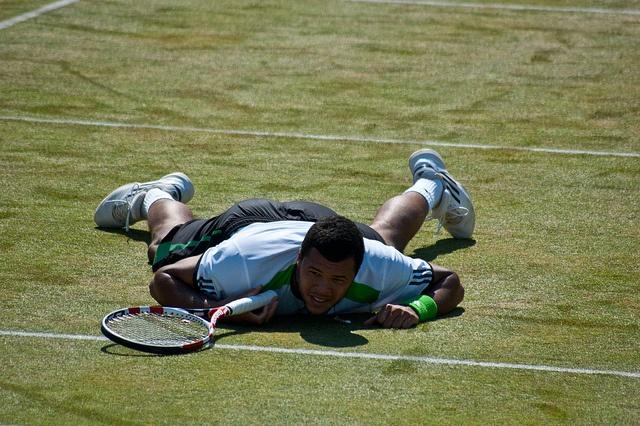Describe the objects in this image and their specific colors. I can see people in olive, black, gray, and lightgray tones and tennis racket in olive, gray, black, darkgray, and lightgray tones in this image. 